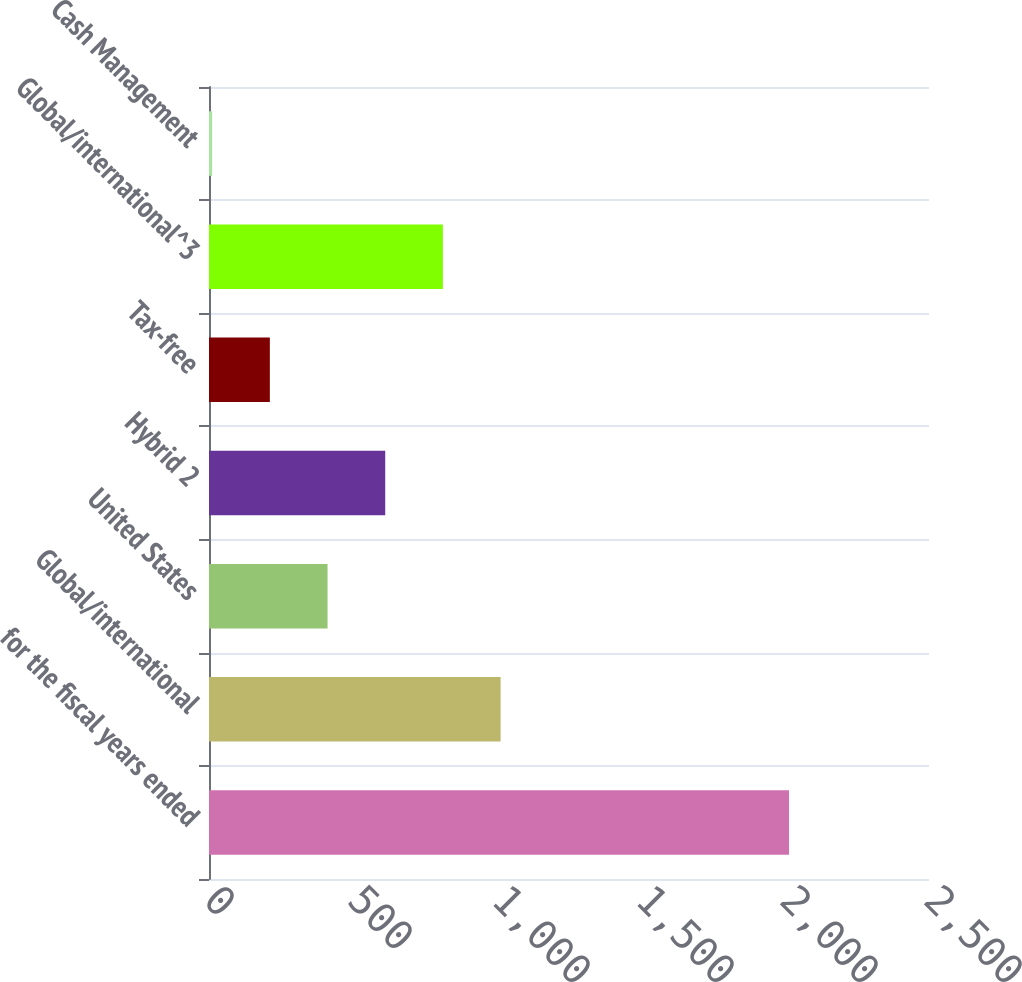Convert chart to OTSL. <chart><loc_0><loc_0><loc_500><loc_500><bar_chart><fcel>for the fiscal years ended<fcel>Global/international<fcel>United States<fcel>Hybrid 2<fcel>Tax-free<fcel>Global/international^3<fcel>Cash Management<nl><fcel>2014<fcel>1012.5<fcel>411.6<fcel>611.9<fcel>211.3<fcel>812.2<fcel>11<nl></chart> 